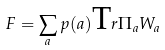Convert formula to latex. <formula><loc_0><loc_0><loc_500><loc_500>F = \sum _ { a } p ( a ) { \text  Tr} \Pi_{a} W_{a}</formula> 